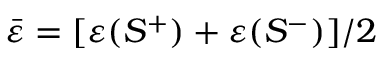Convert formula to latex. <formula><loc_0><loc_0><loc_500><loc_500>\bar { \varepsilon } = [ \varepsilon ( S ^ { + } ) + \varepsilon ( S ^ { - } ) ] / 2</formula> 